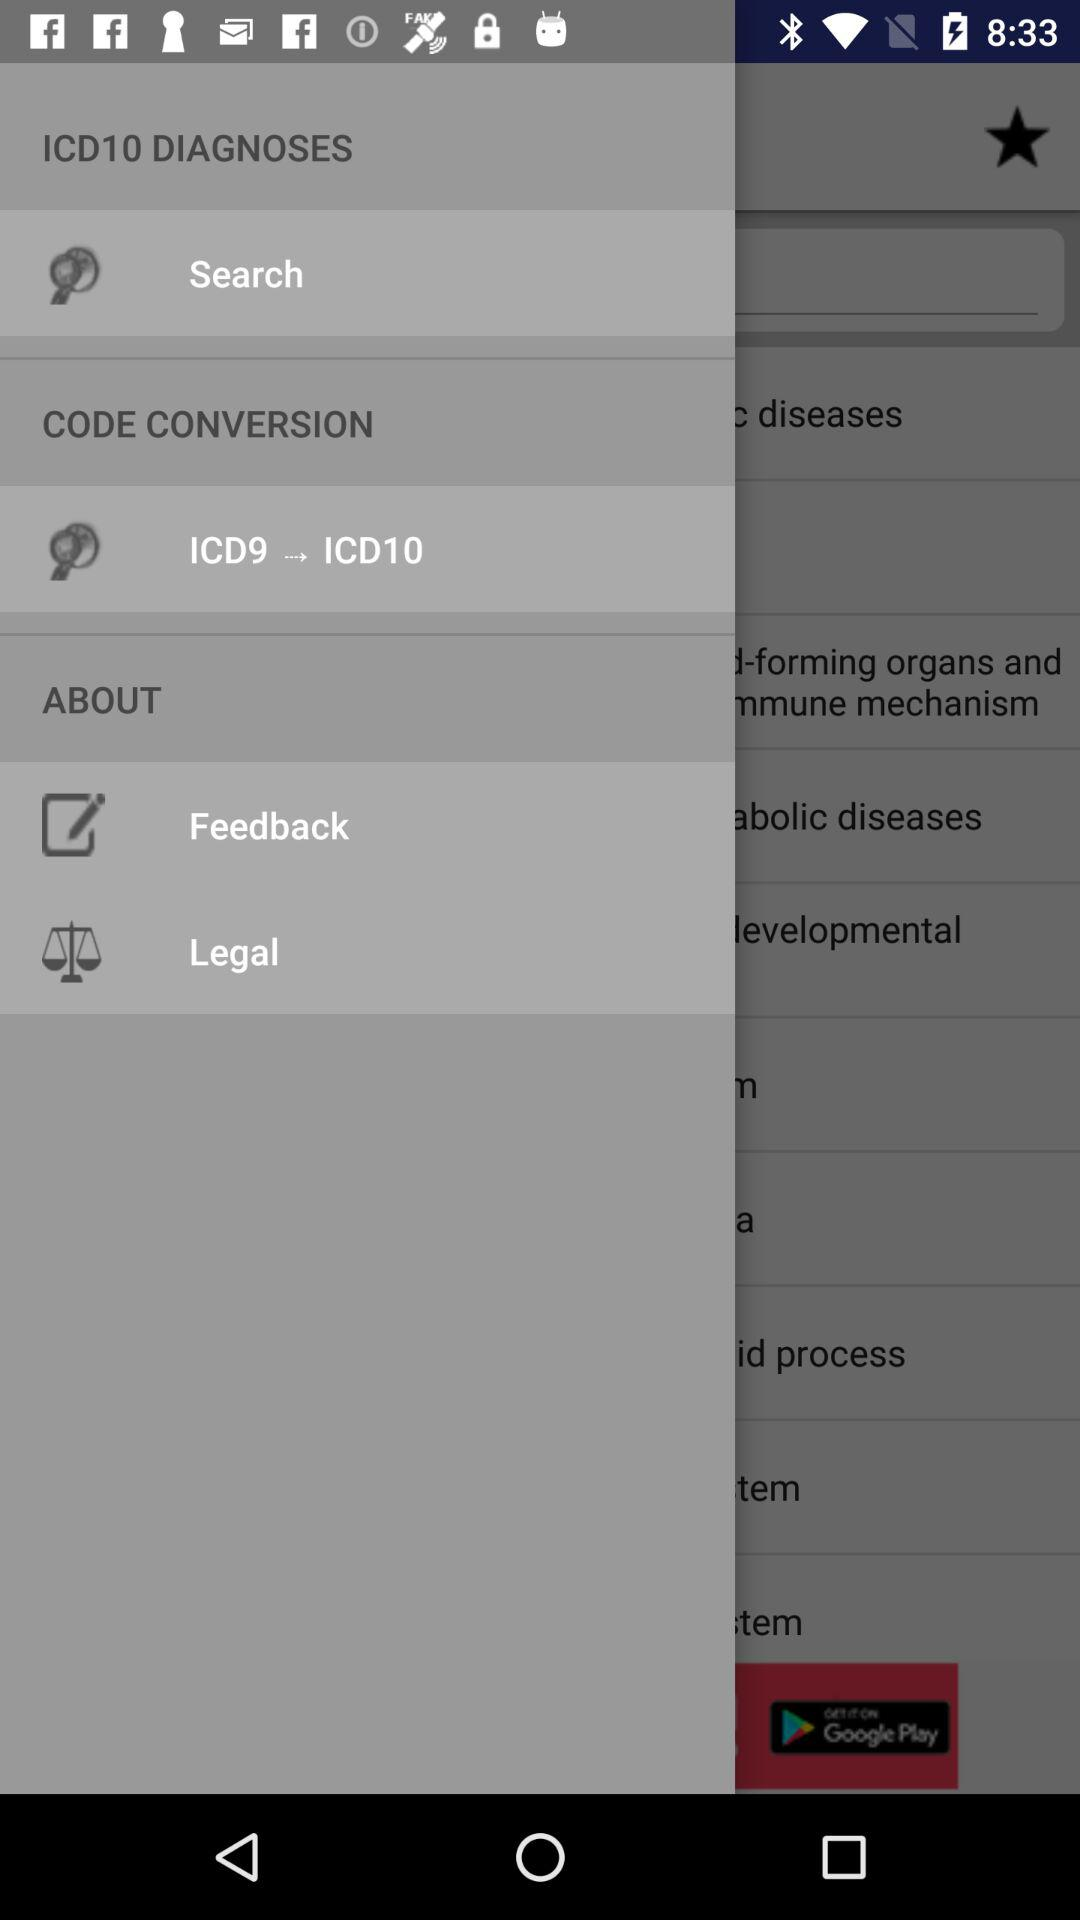What is the "Diagnoses" code? The code is ICD10. 